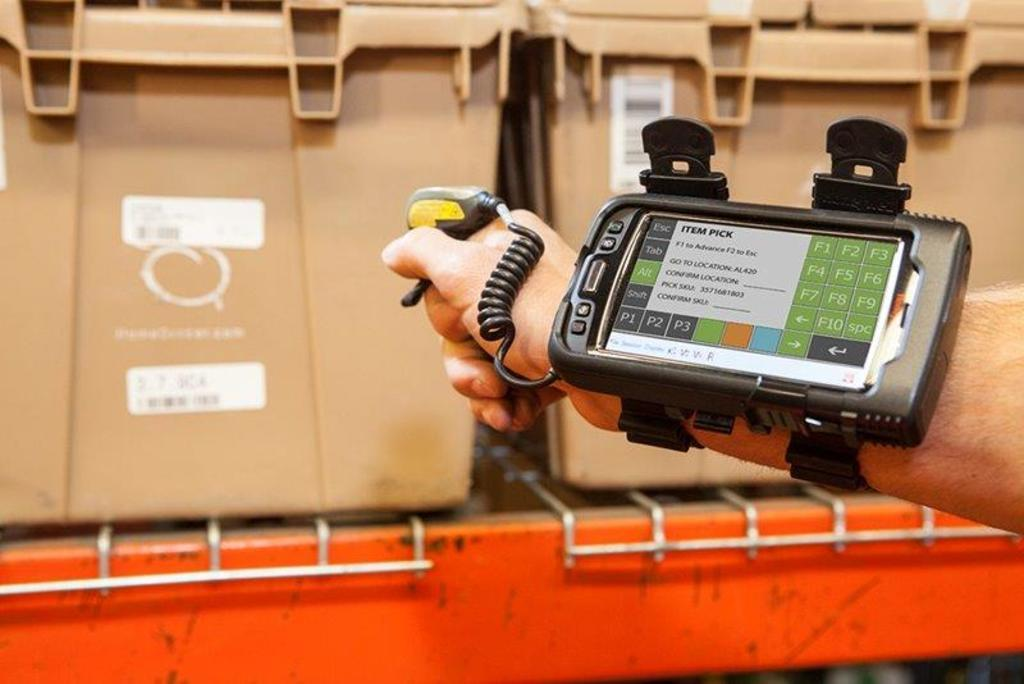<image>
Present a compact description of the photo's key features. A device strapped to someone's arm has an escape option in the upper left corner. 